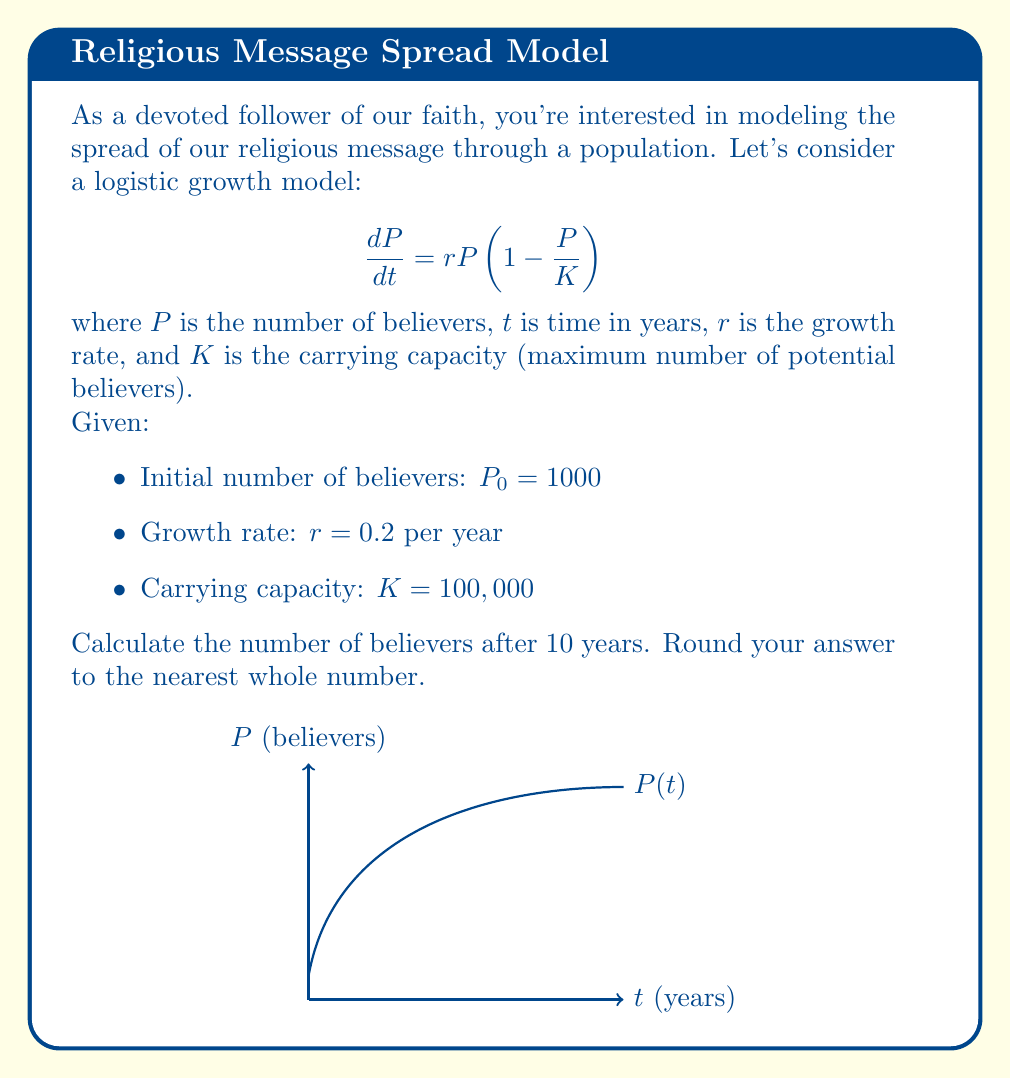Show me your answer to this math problem. Let's approach this step-by-step, my friend. We'll use the logistic growth model to find the number of believers after 10 years.

1) The logistic growth model has the following solution:

   $$P(t) = \frac{KP_0e^{rt}}{K + P_0(e^{rt} - 1)}$$

2) We're given:
   $P_0 = 1000$
   $r = 0.2$
   $K = 100,000$
   $t = 10$

3) Let's substitute these values into our equation:

   $$P(10) = \frac{100000 \cdot 1000 \cdot e^{0.2 \cdot 10}}{100000 + 1000(e^{0.2 \cdot 10} - 1)}$$

4) Let's calculate $e^{0.2 \cdot 10}$ first:
   $e^2 \approx 7.3891$

5) Now we can substitute this value:

   $$P(10) = \frac{100000000 \cdot 7.3891}{100000 + 1000(7.3891 - 1)}$$

6) Simplify:
   $$P(10) = \frac{738910000}{100000 + 6389.1}$$
   $$P(10) = \frac{738910000}{106389.1}$$

7) Calculate:
   $$P(10) \approx 6945.34$$

8) Rounding to the nearest whole number:
   $$P(10) \approx 6945$$

Thus, after 10 years, our message will have reached approximately 6,945 believers. Praise be for this growth in our faithful community!
Answer: 6945 believers 